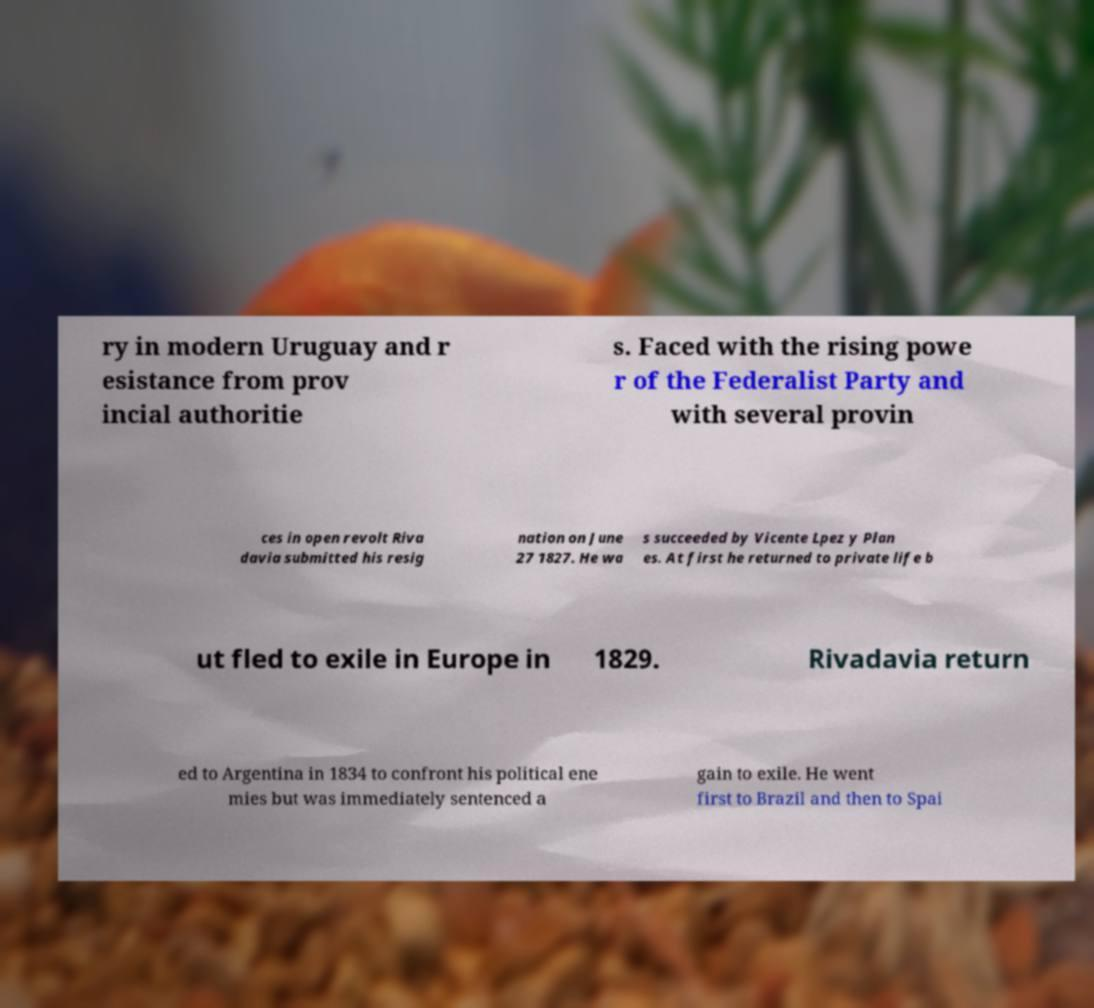There's text embedded in this image that I need extracted. Can you transcribe it verbatim? ry in modern Uruguay and r esistance from prov incial authoritie s. Faced with the rising powe r of the Federalist Party and with several provin ces in open revolt Riva davia submitted his resig nation on June 27 1827. He wa s succeeded by Vicente Lpez y Plan es. At first he returned to private life b ut fled to exile in Europe in 1829. Rivadavia return ed to Argentina in 1834 to confront his political ene mies but was immediately sentenced a gain to exile. He went first to Brazil and then to Spai 